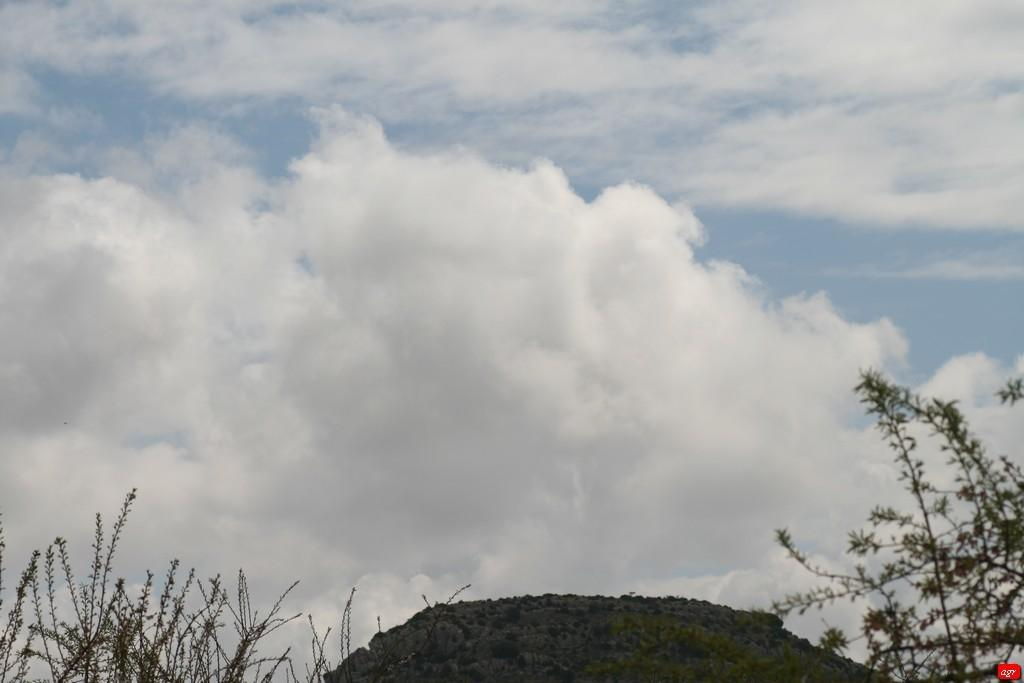What type of vegetation can be seen in the front of the image? There are small plants in the front of the image. What part of the natural environment is visible in the background of the image? The sky is visible in the background of the image. What can be observed in the sky? Clouds are present in the sky. What type of oatmeal is being served in the image? There is no oatmeal present in the image. What type of cap is the person in the image wearing? There is no person or cap visible in the image. 